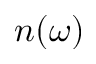Convert formula to latex. <formula><loc_0><loc_0><loc_500><loc_500>n ( \omega )</formula> 